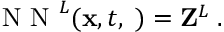Convert formula to latex. <formula><loc_0><loc_0><loc_500><loc_500>\begin{array} { r } { N N ^ { L } ( { x } , t , { \phi } ) = { Z } ^ { L } \, . } \end{array}</formula> 